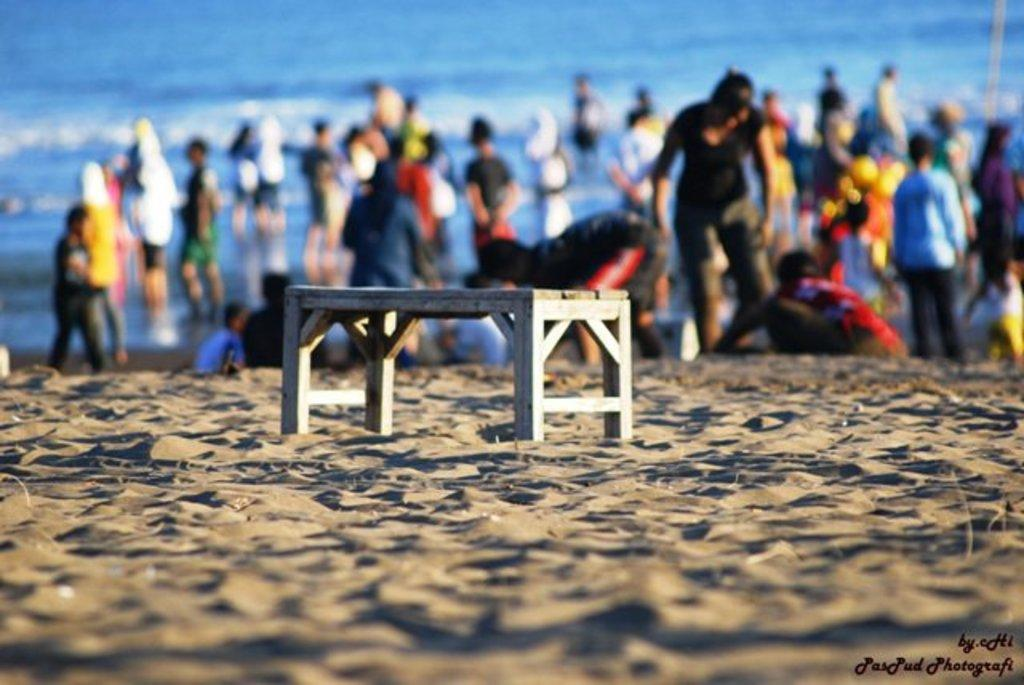What type of seating is present in the image? There is a bench in the image. Where is the bench located? The bench is located on a beach. What can be seen in the background of the image? There are people standing in the water in the background of the image. What is visible in the image besides the bench and people? Water is visible in the image. How many geese are present on the bench in the image? There are no geese present in the image, as it features a bench on a beach with people standing in the water. What type of pleasure can be experienced by the people on the bench in the image? The image does not provide information about the emotions or experiences of the people on the bench, so it is impossible to determine the type of pleasure they might be experiencing. 